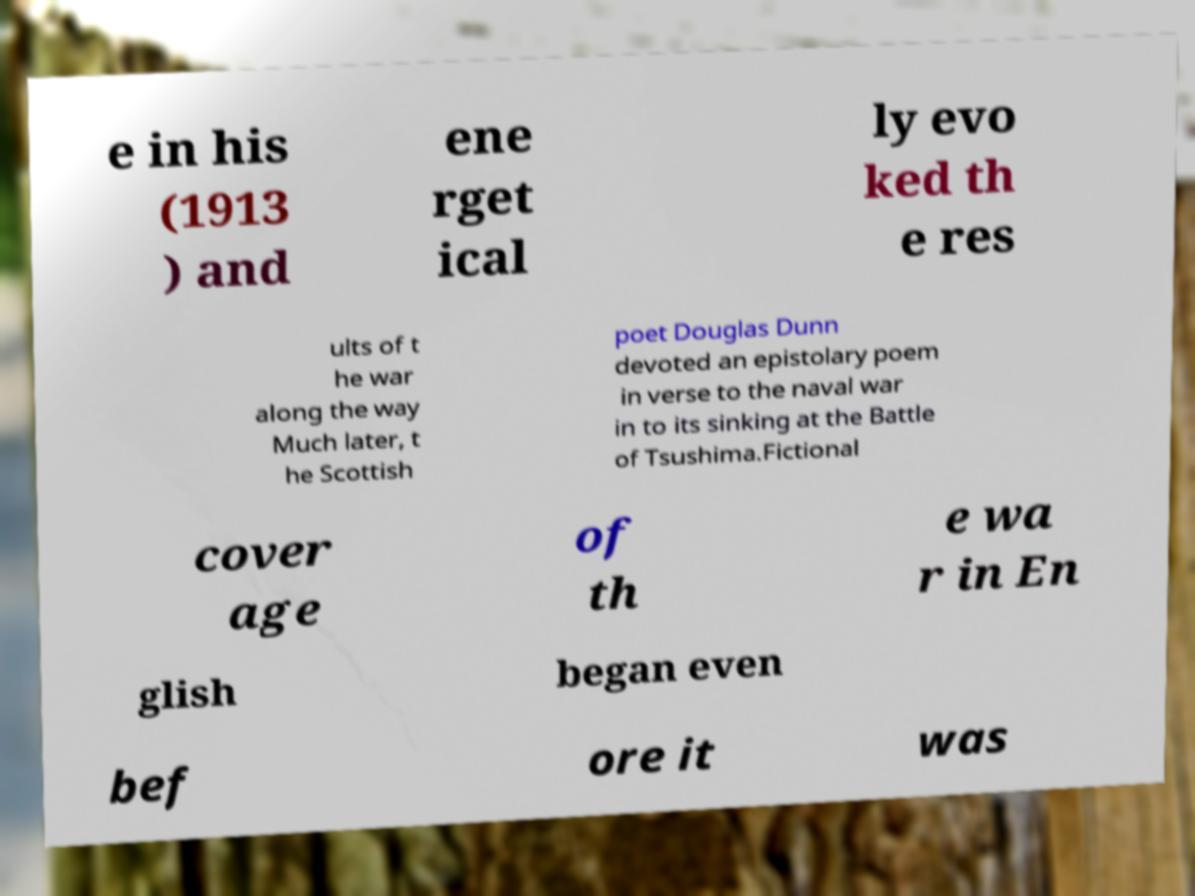Please read and relay the text visible in this image. What does it say? e in his (1913 ) and ene rget ical ly evo ked th e res ults of t he war along the way Much later, t he Scottish poet Douglas Dunn devoted an epistolary poem in verse to the naval war in to its sinking at the Battle of Tsushima.Fictional cover age of th e wa r in En glish began even bef ore it was 